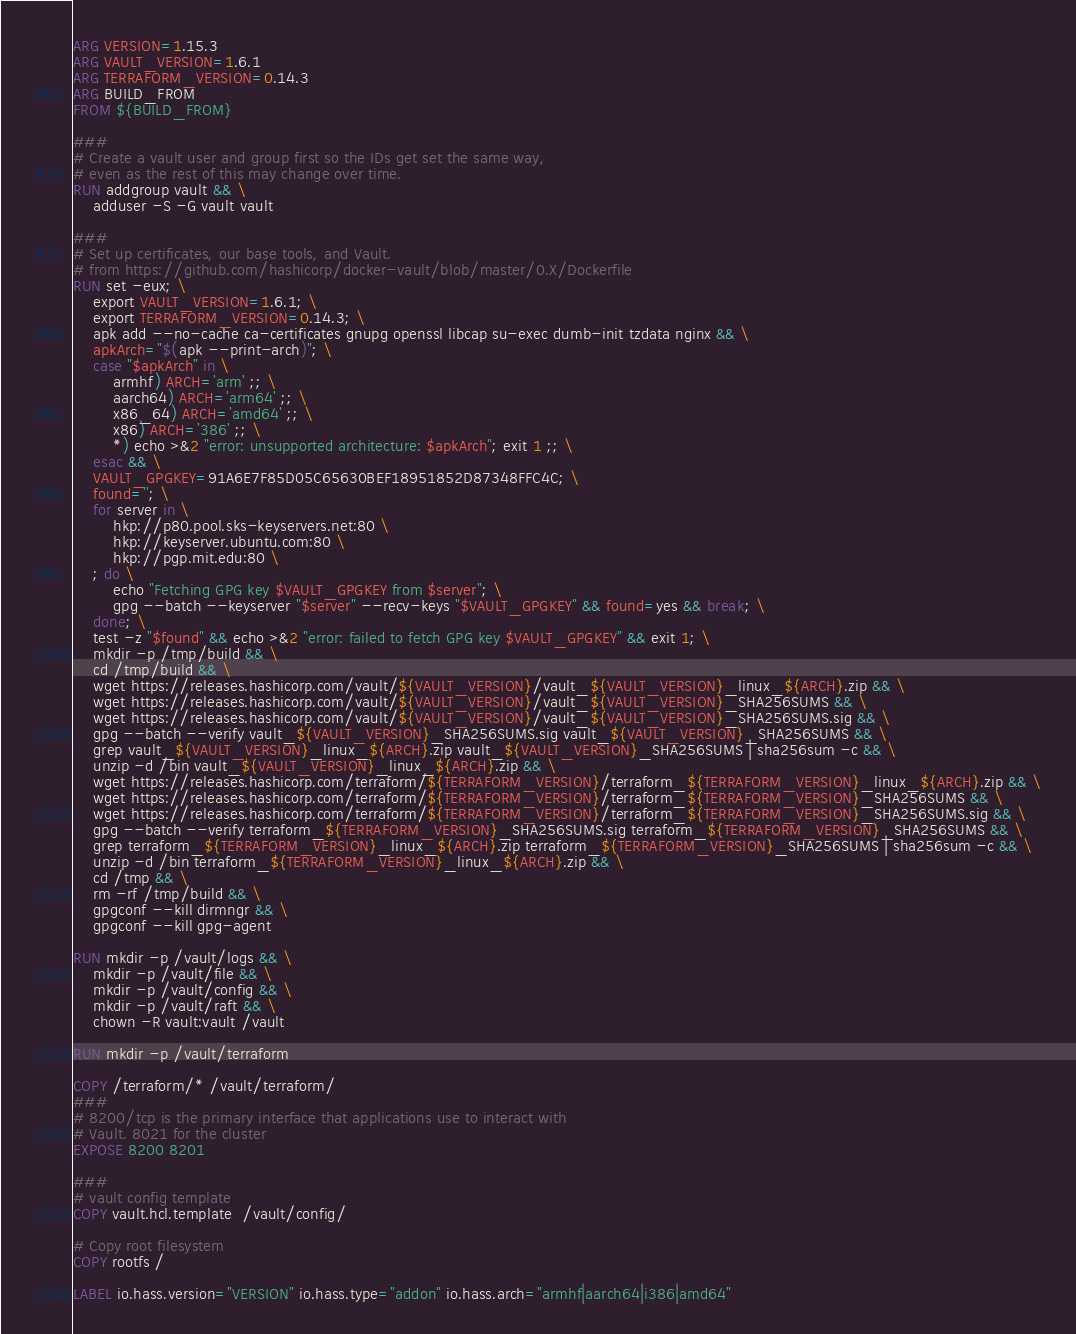Convert code to text. <code><loc_0><loc_0><loc_500><loc_500><_Dockerfile_>ARG VERSION=1.15.3
ARG VAULT_VERSION=1.6.1
ARG TERRAFORM_VERSION=0.14.3
ARG BUILD_FROM
FROM ${BUILD_FROM}

###
# Create a vault user and group first so the IDs get set the same way,
# even as the rest of this may change over time.
RUN addgroup vault && \
    adduser -S -G vault vault

###
# Set up certificates, our base tools, and Vault.
# from https://github.com/hashicorp/docker-vault/blob/master/0.X/Dockerfile
RUN set -eux; \
    export VAULT_VERSION=1.6.1; \
    export TERRAFORM_VERSION=0.14.3; \
    apk add --no-cache ca-certificates gnupg openssl libcap su-exec dumb-init tzdata nginx && \
    apkArch="$(apk --print-arch)"; \
    case "$apkArch" in \
        armhf) ARCH='arm' ;; \
        aarch64) ARCH='arm64' ;; \
        x86_64) ARCH='amd64' ;; \
        x86) ARCH='386' ;; \
        *) echo >&2 "error: unsupported architecture: $apkArch"; exit 1 ;; \
    esac && \
    VAULT_GPGKEY=91A6E7F85D05C65630BEF18951852D87348FFC4C; \
    found=''; \
    for server in \
        hkp://p80.pool.sks-keyservers.net:80 \
        hkp://keyserver.ubuntu.com:80 \
        hkp://pgp.mit.edu:80 \
    ; do \
        echo "Fetching GPG key $VAULT_GPGKEY from $server"; \
        gpg --batch --keyserver "$server" --recv-keys "$VAULT_GPGKEY" && found=yes && break; \
    done; \
    test -z "$found" && echo >&2 "error: failed to fetch GPG key $VAULT_GPGKEY" && exit 1; \
    mkdir -p /tmp/build && \
    cd /tmp/build && \
    wget https://releases.hashicorp.com/vault/${VAULT_VERSION}/vault_${VAULT_VERSION}_linux_${ARCH}.zip && \
    wget https://releases.hashicorp.com/vault/${VAULT_VERSION}/vault_${VAULT_VERSION}_SHA256SUMS && \
    wget https://releases.hashicorp.com/vault/${VAULT_VERSION}/vault_${VAULT_VERSION}_SHA256SUMS.sig && \
    gpg --batch --verify vault_${VAULT_VERSION}_SHA256SUMS.sig vault_${VAULT_VERSION}_SHA256SUMS && \
    grep vault_${VAULT_VERSION}_linux_${ARCH}.zip vault_${VAULT_VERSION}_SHA256SUMS | sha256sum -c && \
    unzip -d /bin vault_${VAULT_VERSION}_linux_${ARCH}.zip && \
    wget https://releases.hashicorp.com/terraform/${TERRAFORM_VERSION}/terraform_${TERRAFORM_VERSION}_linux_${ARCH}.zip && \
    wget https://releases.hashicorp.com/terraform/${TERRAFORM_VERSION}/terraform_${TERRAFORM_VERSION}_SHA256SUMS && \
    wget https://releases.hashicorp.com/terraform/${TERRAFORM_VERSION}/terraform_${TERRAFORM_VERSION}_SHA256SUMS.sig && \
    gpg --batch --verify terraform_${TERRAFORM_VERSION}_SHA256SUMS.sig terraform_${TERRAFORM_VERSION}_SHA256SUMS && \
    grep terraform_${TERRAFORM_VERSION}_linux_${ARCH}.zip terraform_${TERRAFORM_VERSION}_SHA256SUMS | sha256sum -c && \
    unzip -d /bin terraform_${TERRAFORM_VERSION}_linux_${ARCH}.zip && \
    cd /tmp && \
    rm -rf /tmp/build && \
    gpgconf --kill dirmngr && \
    gpgconf --kill gpg-agent

RUN mkdir -p /vault/logs && \
    mkdir -p /vault/file && \
    mkdir -p /vault/config && \
    mkdir -p /vault/raft && \
    chown -R vault:vault /vault

RUN mkdir -p /vault/terraform

COPY /terraform/* /vault/terraform/
###
# 8200/tcp is the primary interface that applications use to interact with
# Vault. 8021 for the cluster
EXPOSE 8200 8201

###
# vault config template
COPY vault.hcl.template  /vault/config/

# Copy root filesystem
COPY rootfs /

LABEL io.hass.version="VERSION" io.hass.type="addon" io.hass.arch="armhf|aarch64|i386|amd64"
</code> 